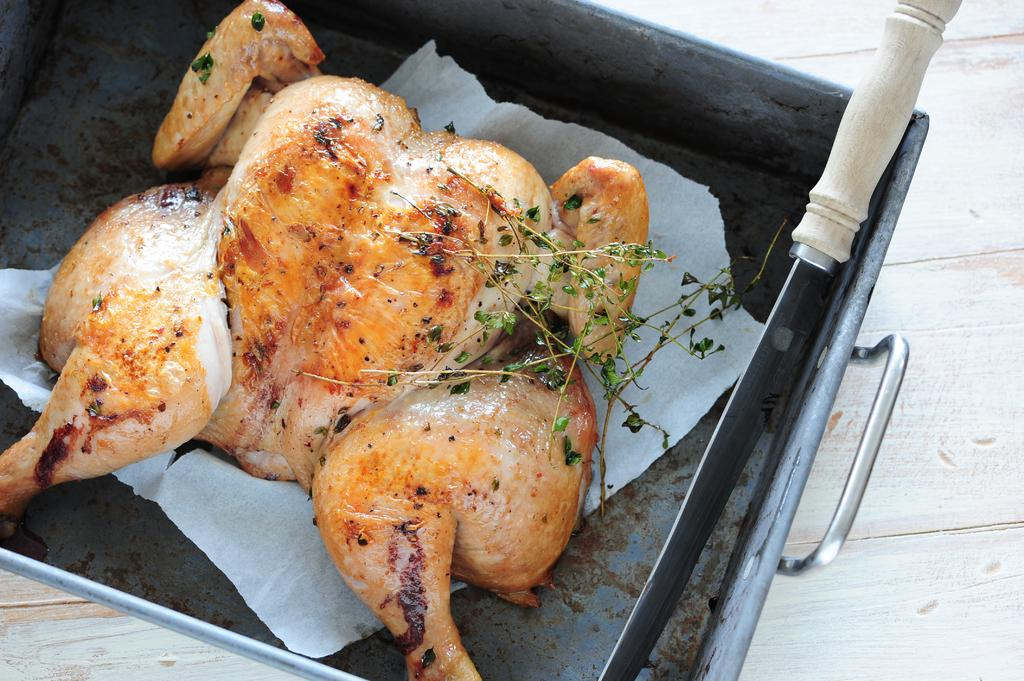What is the main subject in the center of the image? There is a roasted chicken in the center of the image. What object is located on the right side of the image? There appears to be a knife on the right side of the image. What type of furniture is present in the image? There is no furniture visible in the image. What is the zinc content of the roasted chicken in the image? The zinc content of the roasted chicken cannot be determined from the image. 